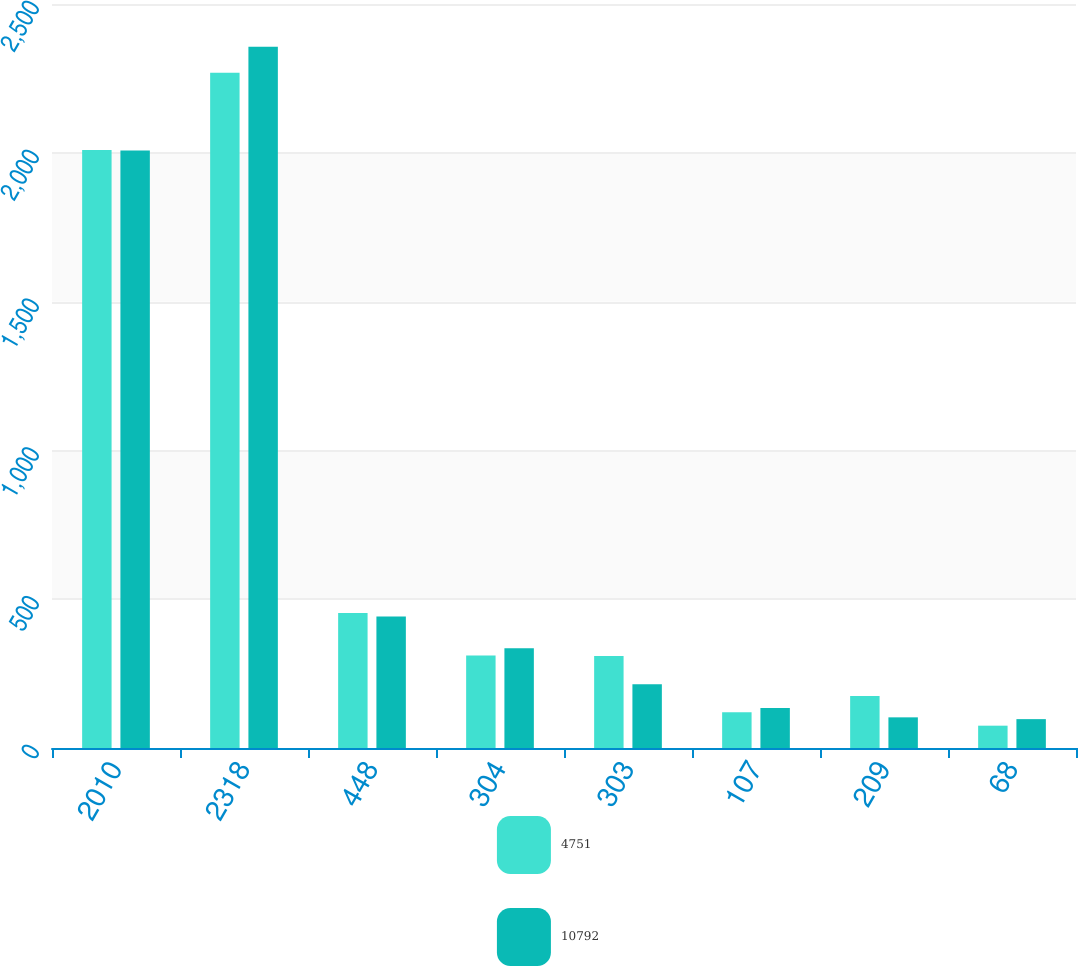Convert chart. <chart><loc_0><loc_0><loc_500><loc_500><stacked_bar_chart><ecel><fcel>2010<fcel>2318<fcel>448<fcel>304<fcel>303<fcel>107<fcel>209<fcel>68<nl><fcel>4751<fcel>2009<fcel>2269<fcel>454<fcel>311<fcel>309<fcel>120<fcel>175<fcel>75<nl><fcel>10792<fcel>2008<fcel>2356<fcel>442<fcel>335<fcel>214<fcel>134<fcel>103<fcel>97<nl></chart> 